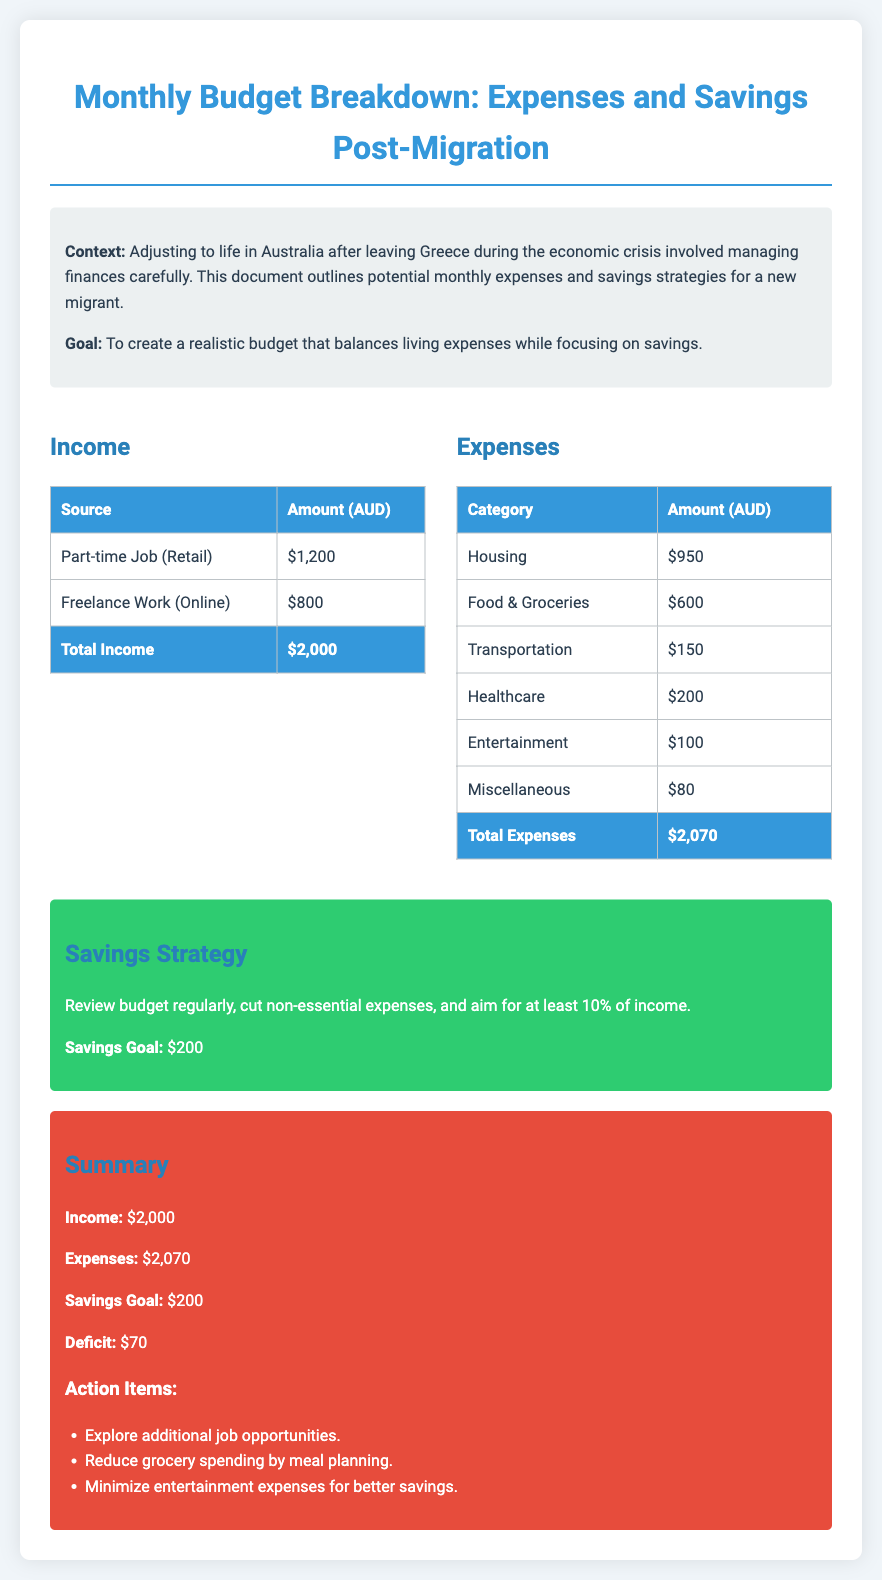what is the total income? The total income is listed at the bottom of the income section, calculated as the sum of all sources, which is $1,200 + $800.
Answer: $2,000 what is the total expenses? The total expenses are indicated at the bottom of the expenses table, which adds up all expense categories, totaling $950 + $600 + $150 + $200 + $100 + $80.
Answer: $2,070 what is the monthly savings goal? The savings goal is stated in the savings strategy section, which highlights the aim for savings each month.
Answer: $200 how much is the deficit? The deficit is calculated by subtracting total expenses from total income, which is $2,000 - $2,070.
Answer: $70 which category has the highest expense? By reviewing the expenses table, Housing has the largest amount listed as an expense.
Answer: Housing what strategy is suggested for savings? The savings strategy section outlines methods to save money, which includes reviewing the budget regularly.
Answer: Review budget regularly what is the amount allocated for transportation? The transportation expense is specifically listed in the expenses table with its allocated amount.
Answer: $150 how much is budgeted for healthcare? The amount for healthcare is directly provided in the expenses section.
Answer: $200 what are the action items mentioned in the summary? The summary provides specific actions to take, listed under "Action Items," which includes exploring additional job opportunities.
Answer: Explore additional job opportunities 